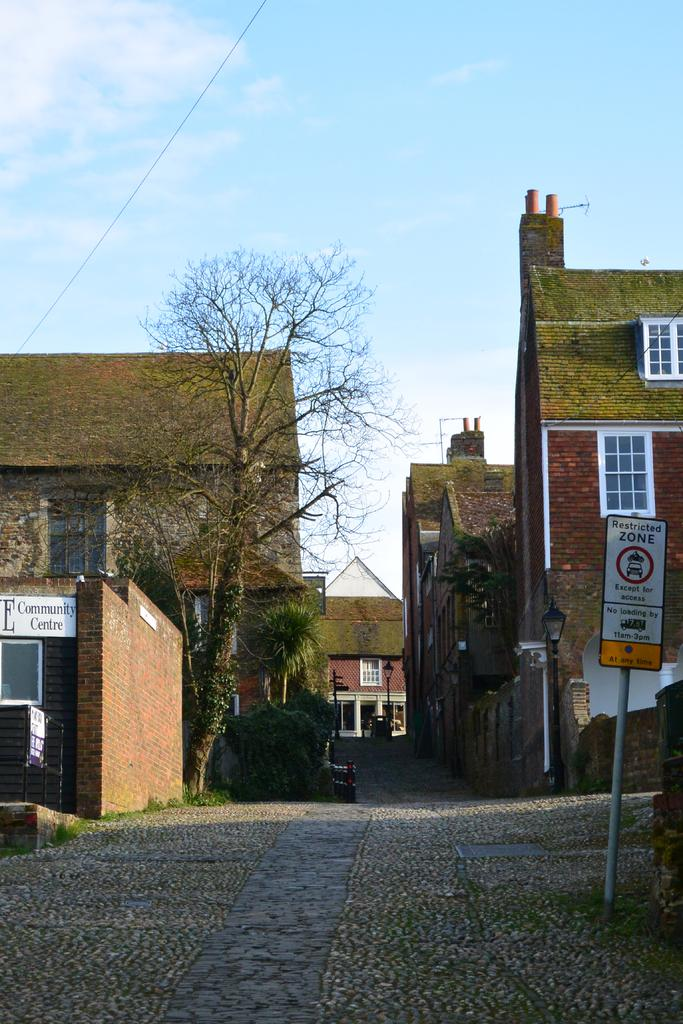What type of structures can be seen in the image? There are buildings in the image. What can be found on the buildings in the image? There are name boards on the buildings in the image. What can be seen illuminating the scene in the image? There are lights in the image. What type of vegetation is present in the image? There are trees in the image. What type of material is used for the walls of the buildings in the image? There are brick walls in the image. What is visible in the background of the image? The sky is visible in the background of the image. What is the rate of the force applied to the trees in the image? There is no information about force or rates in the image; it only shows buildings, name boards, lights, trees, brick walls, and the sky. 